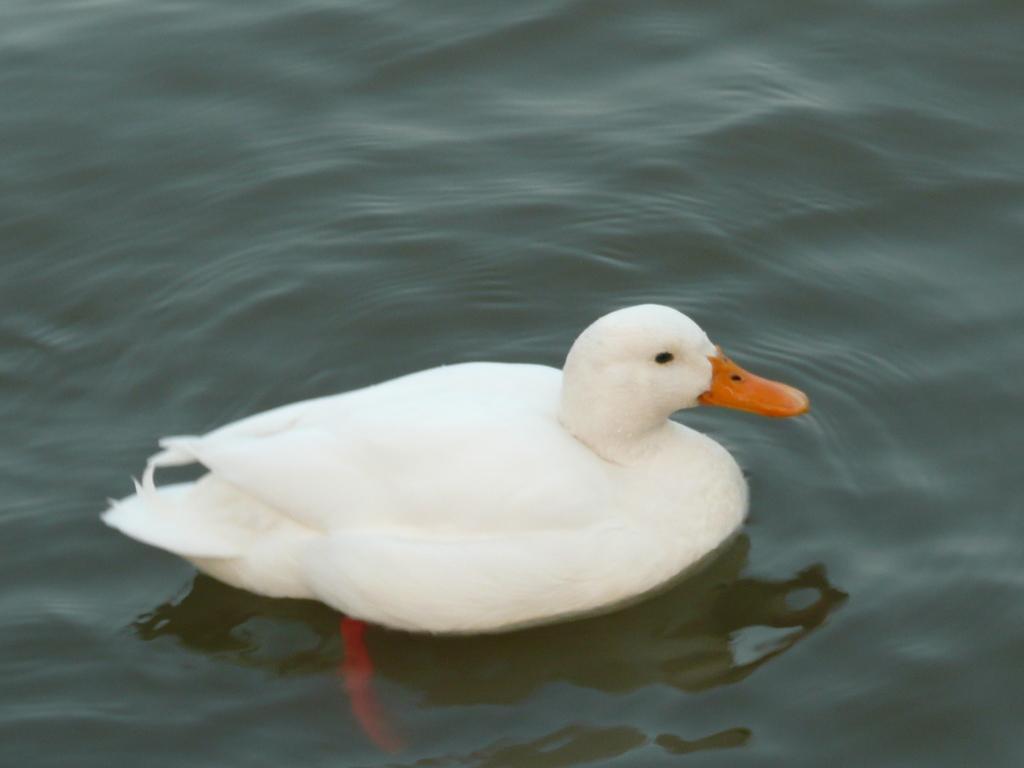Could you give a brief overview of what you see in this image? In this picture we can see duck and water. 